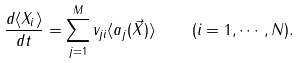Convert formula to latex. <formula><loc_0><loc_0><loc_500><loc_500>\frac { d \langle X _ { i } \rangle } { d t } = \sum _ { j = 1 } ^ { M } v _ { j i } \langle a _ { j } ( \vec { X } ) \rangle \quad ( i = 1 , \cdots , N ) .</formula> 